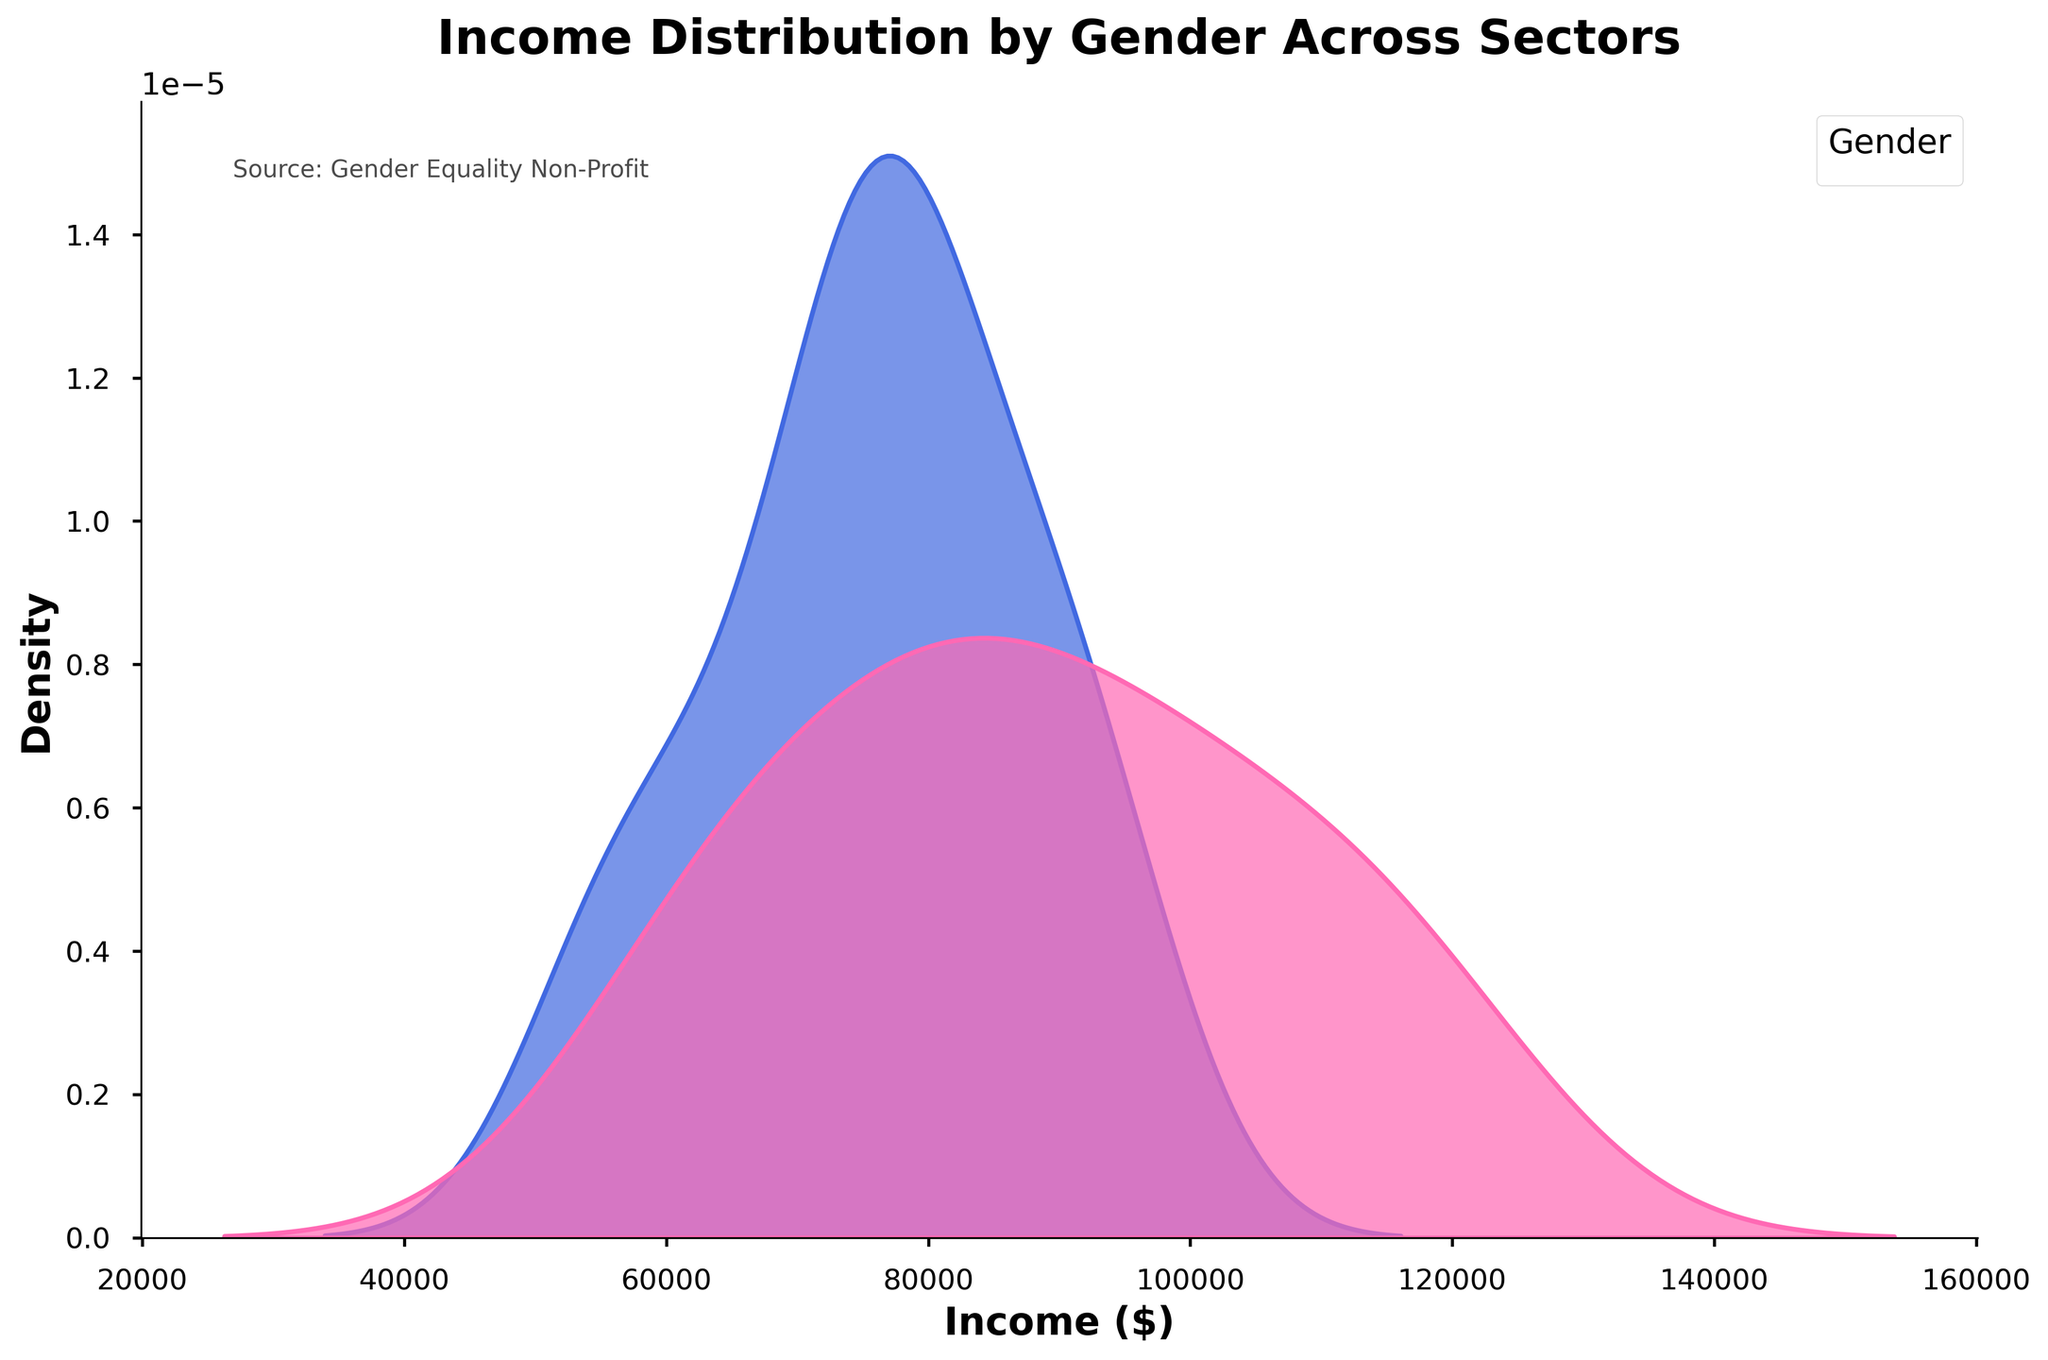What is the title of the figure? The title is usually placed at the top of the figure and provides a brief description of what the figure is about. In this case, it is "Income Distribution by Gender Across Sectors".
Answer: Income Distribution by Gender Across Sectors What does the x-axis represent in the figure? The x-axis in the figure represents the variable whose distribution is being plotted. In this case, it represents the incomes in dollars.
Answer: Income ($) What color represents the male income distribution? In the figure, a specific color is used to represent each gender. By referring to the code, it is known that males are represented by royal blue.
Answer: Royal Blue Which gender shows a wider income distribution? A wider distribution appears as a broader curve in the plot. By comparing the curves, the one with more spread along the x-axis indicates a wider distribution.
Answer: Male What is the approximate peak (mode) income for females? The peak of the distribution curve represents the most frequent income value. For females, this peak can be visually estimated from the distplot.
Answer: Approximately $75,000 Which gender has a higher average income in the technology sector? Higher average income can be identified by the peak or central tendency of the curves. The curve with the peak further to the right indicates a higher average income. For technology, it is the males with peaks approximately around $110,000.
Answer: Male In which sector do females have the least income distribution spread? By examining the width of the female curves in different sectors, the one with the narrowest spread along the x-axis represents the least spread in income distribution.
Answer: Retail What sector has the highest base median income for both genders? The base median income is roughly the point where the density curves of both genders are centered. By looking at the different sectors visually, it is seen that Finance has the highest base median income for both genders.
Answer: Finance Are there any sectors where female income distribution significantly overlaps or surpasses male income distribution? Significant overlap or surpassing will be visible where the density curves of females are not just overlapping but peaking higher or being more prominent over the male curves.
Answer: No Comparing education and healthcare, which sector shows a smaller gender income gap based on the figure? To determine the smaller gender income gap, examine the proximity of the peaks or the central tendencies of the male and female curves. Closer peaks suggest a smaller income gap.
Answer: Education 